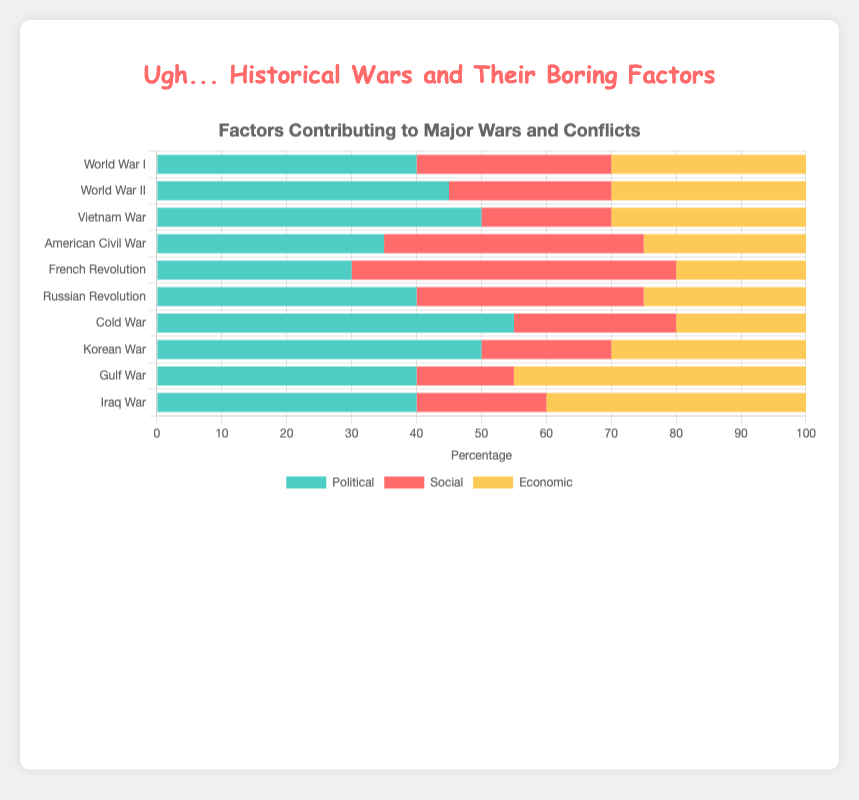Which conflict has the highest social contribution factor? Look at the heights of the red sections of the bars and identify which one is the tallest. The French Revolution has the highest social factor at 50%.
Answer: French Revolution Between World War I and II, which conflict has a higher political contribution? Compare the blue sections of the bars for World War I (40%) and World War II (45%). World War II has a higher political factor.
Answer: World War II Which conflict has the lowest economic contribution? Check the yellow sections of all bars and identify the shortest one. The French Revolution has the lowest economic contribution at 20%.
Answer: French Revolution What is the combined political and social contribution for the Vietnam War? Add the height of the blue section (50%) and the red section (20%) of the Vietnam War bar. The combined contribution is 50% + 20% = 70%.
Answer: 70% How does the economic contribution of the Gulf War compare to the Iraq War? Compare the yellow sections of the bars for the Gulf War (45%) and the Iraq War (40%). The Gulf War has a higher economic contribution.
Answer: Gulf War Which conflict has the smallest social contribution and what is its value? Look for the shortest red section across all bars. The Gulf War has the smallest social factor at 15%.
Answer: Gulf War, 15% What is the average political contribution across all conflicts? (40 + 45 + 50 + 35 + 30 + 40 + 55 + 50 + 40 + 40) / 10 = 425 / 10. Calculate the sum of the political percentages and divide by the number of conflicts.
Answer: 42.5% Which conflict has an equal political and economic contribution factor? Find the conflict where the blue and yellow sections are the same height. Both World War I and World War II have equal political and economic factors of 40% and 30%, respectively.
Answer: World War I, World War II 